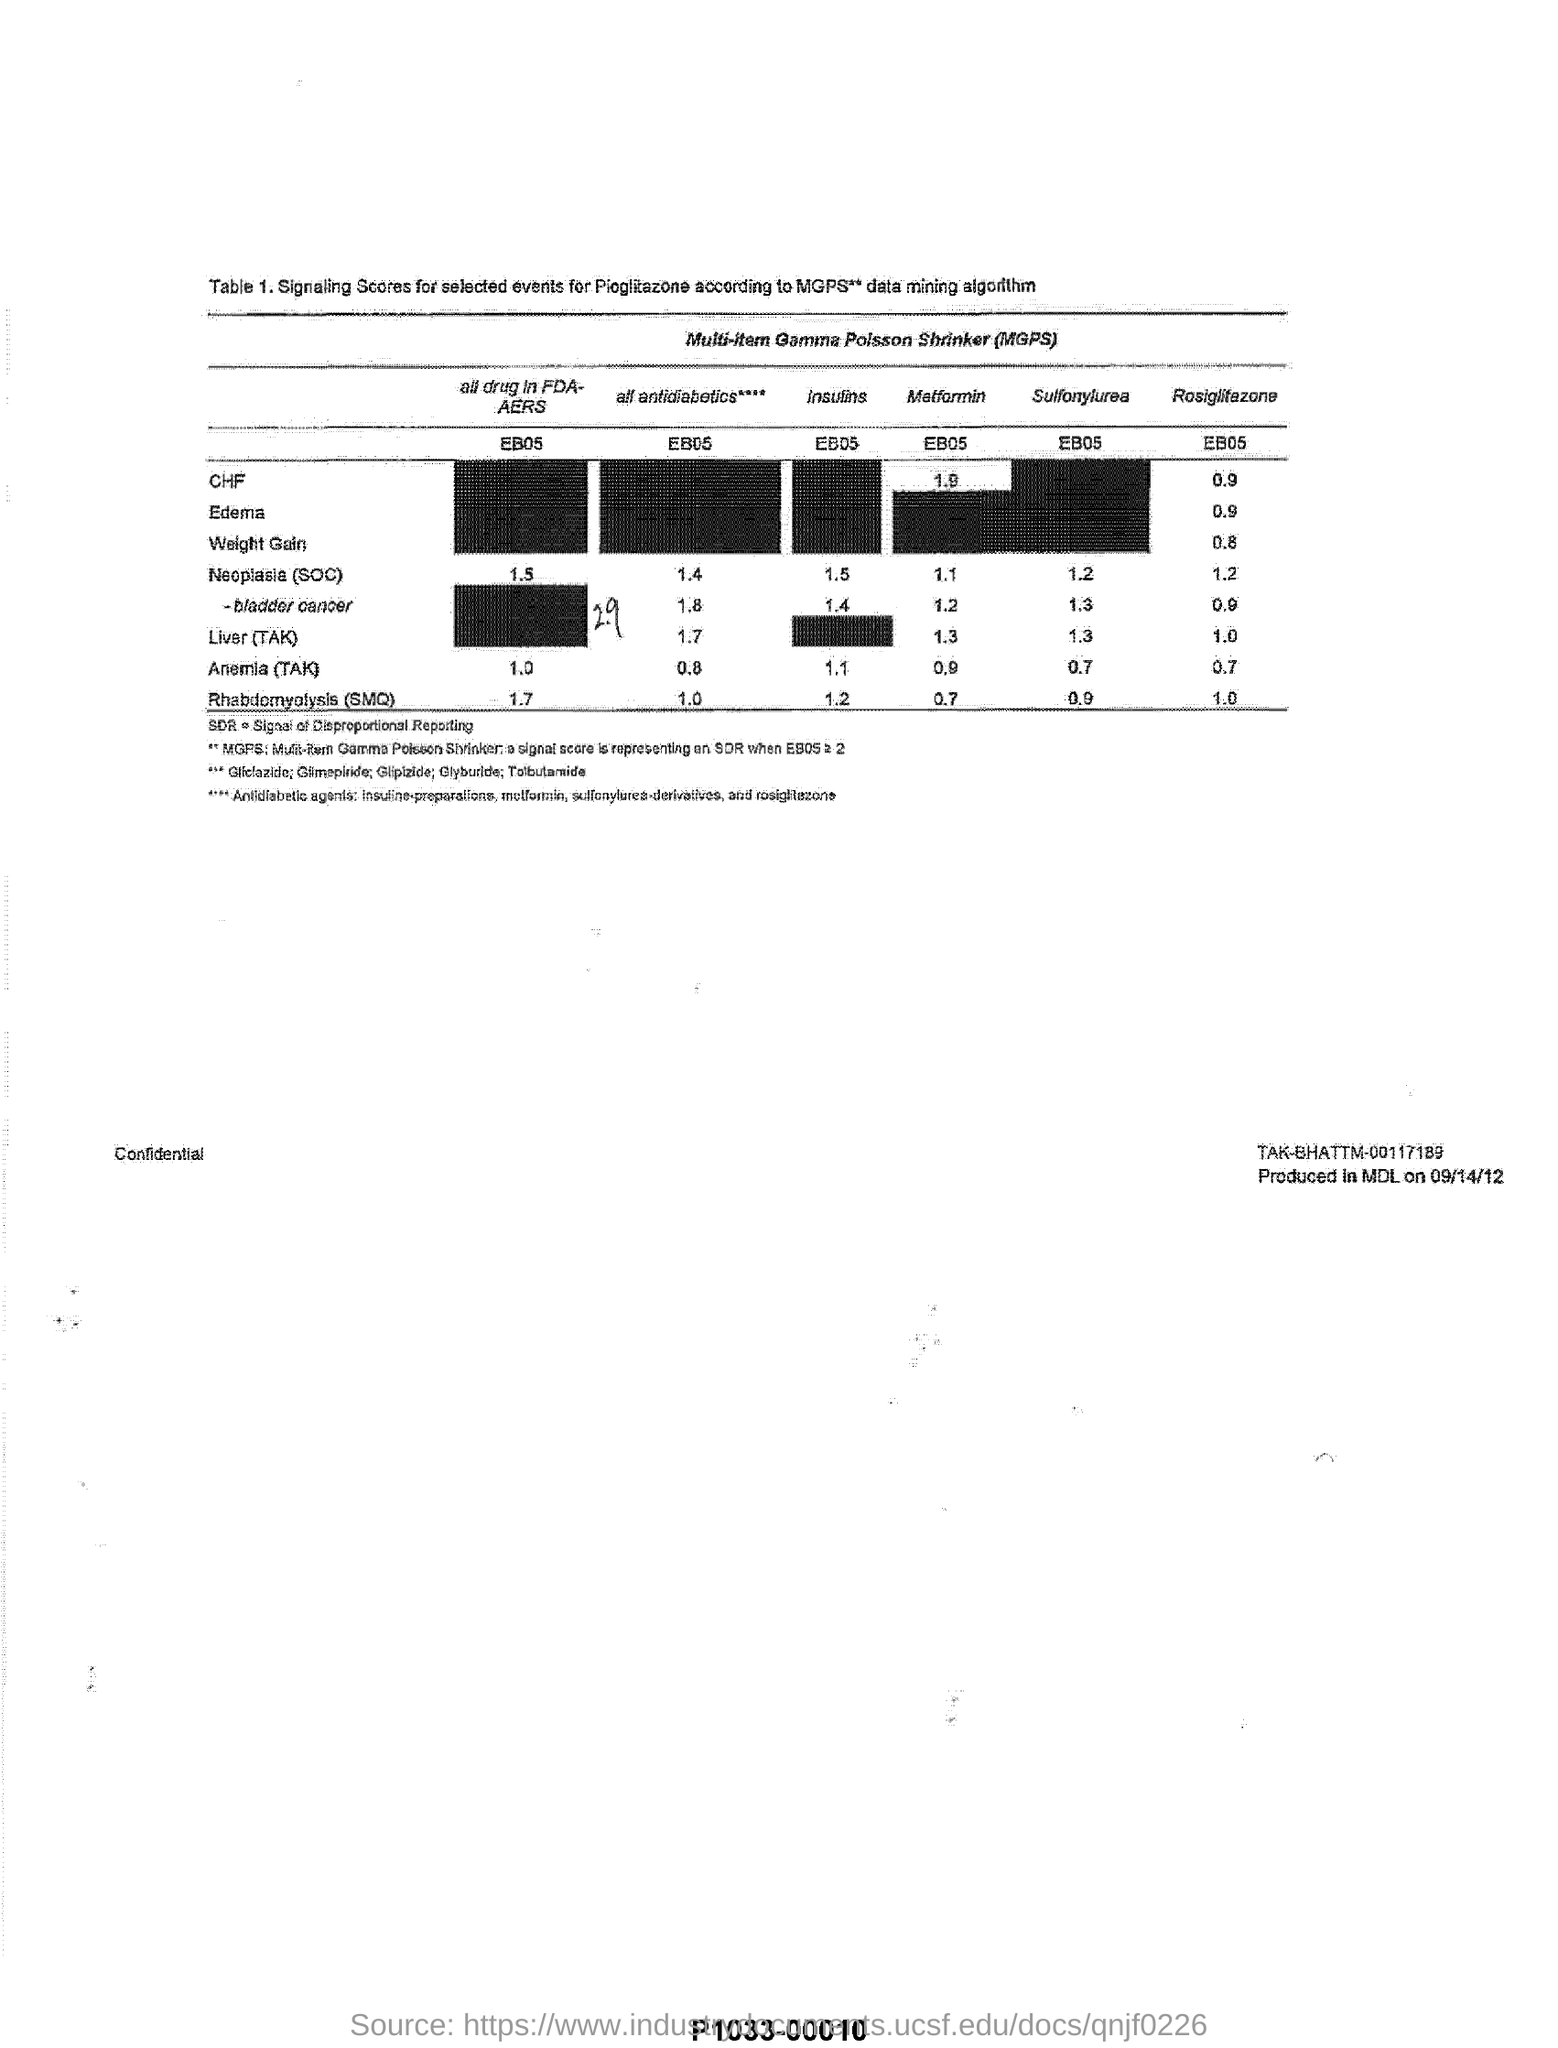What algorithm is mentioned in table 1 heading
Offer a terse response. MGPS** data mining algorithm. 